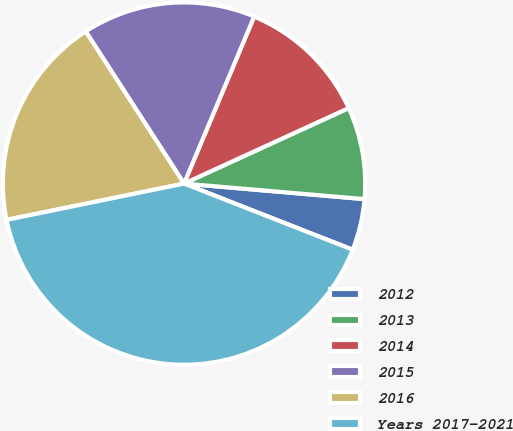Convert chart to OTSL. <chart><loc_0><loc_0><loc_500><loc_500><pie_chart><fcel>2012<fcel>2013<fcel>2014<fcel>2015<fcel>2016<fcel>Years 2017-2021<nl><fcel>4.58%<fcel>8.21%<fcel>11.83%<fcel>15.46%<fcel>19.08%<fcel>40.84%<nl></chart> 